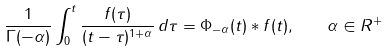<formula> <loc_0><loc_0><loc_500><loc_500>\frac { 1 } { \Gamma ( - \alpha ) } \int ^ { t } _ { 0 } \frac { f ( \tau ) } { ( t - \tau ) ^ { 1 + \alpha } } \, d \tau = \Phi _ { - \alpha } ( t ) * f ( t ) , \quad \alpha \in { R ^ { + } }</formula> 